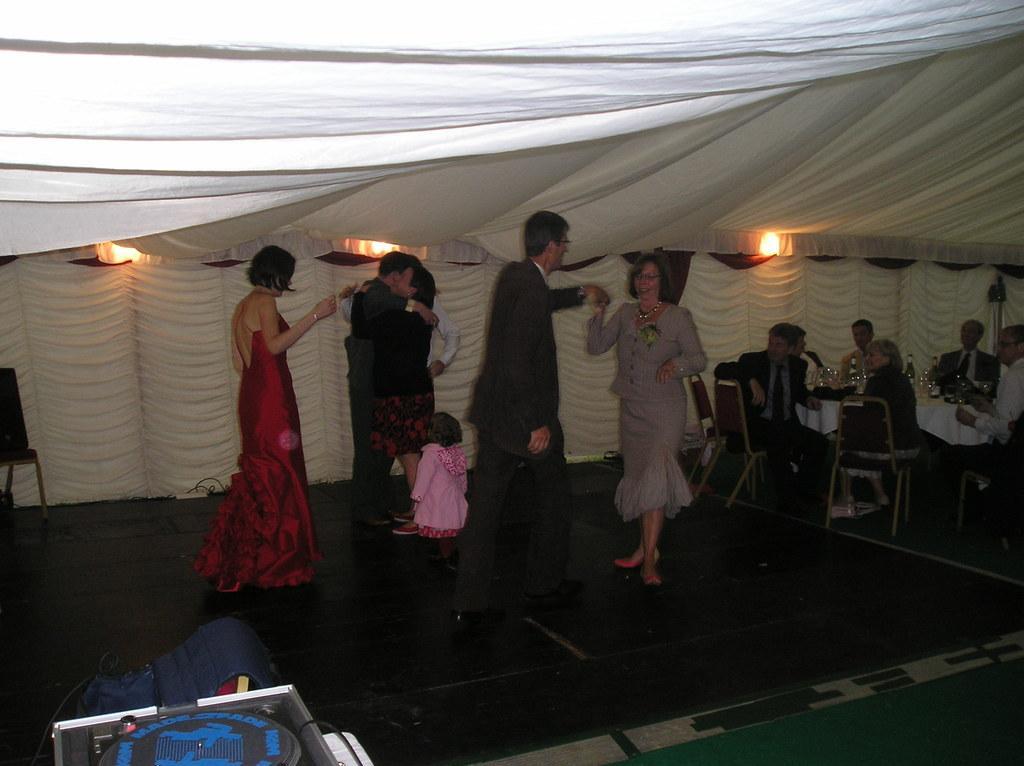Can you describe this image briefly? In the center of the image we can see some persons are dancing. On the right side of the image we can see a table. On the table we can see a cloth, bottles, glasses. Beside a table we can see some persons are sitting on the chairs. In the background of the image we can see the clothes and lights. On the left side of the image we can see a chair. At the bottom of the image we can see an object. In the background of the image we can see the floor and carpet. 